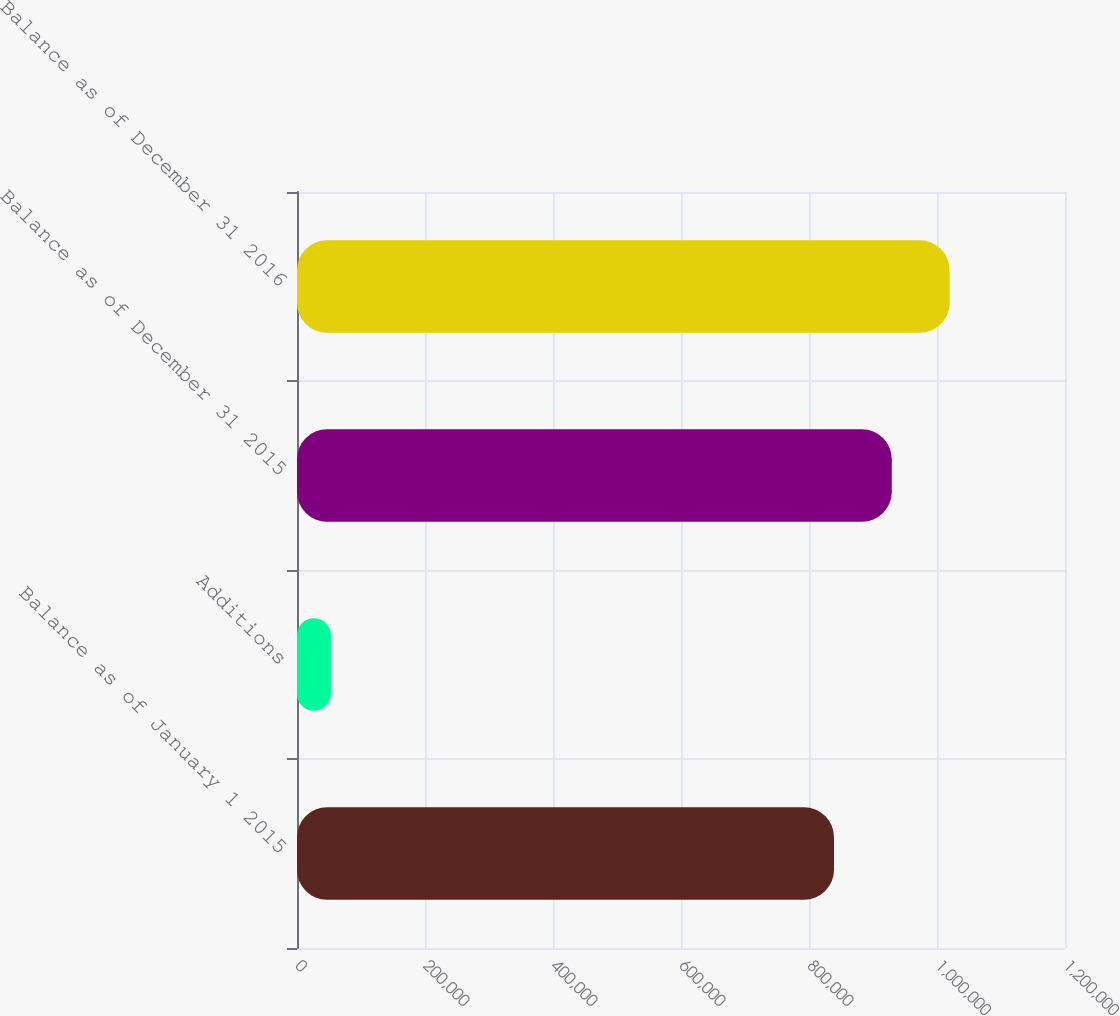Convert chart. <chart><loc_0><loc_0><loc_500><loc_500><bar_chart><fcel>Balance as of January 1 2015<fcel>Additions<fcel>Balance as of December 31 2015<fcel>Balance as of December 31 2016<nl><fcel>839075<fcel>52952<fcel>929395<fcel>1.01972e+06<nl></chart> 